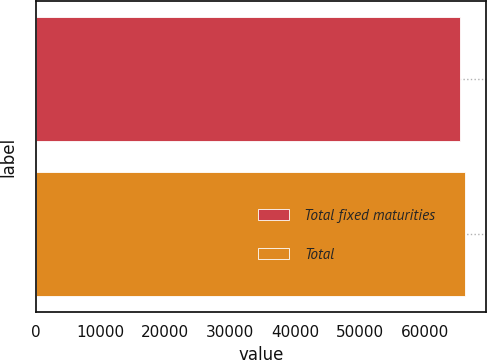Convert chart to OTSL. <chart><loc_0><loc_0><loc_500><loc_500><bar_chart><fcel>Total fixed maturities<fcel>Total<nl><fcel>65393<fcel>66138<nl></chart> 